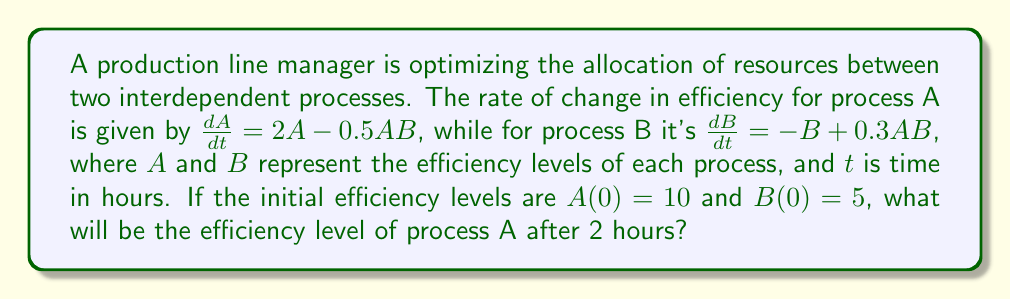Can you answer this question? To solve this problem, we need to use a numerical method to approximate the solution of the system of ordinary differential equations. We'll use the fourth-order Runge-Kutta method (RK4) for its accuracy.

The system of ODEs is:

$$\begin{cases}
\frac{dA}{dt} = 2A - 0.5AB \\
\frac{dB}{dt} = -B + 0.3AB
\end{cases}$$

With initial conditions: $A(0) = 10$, $B(0) = 5$

Let's define the step size $h = 0.1$ hours, so we'll have 20 steps to reach 2 hours.

The RK4 method for a system of two ODEs is given by:

$$\begin{aligned}
k_1^A &= h f(t_n, A_n, B_n) \\
k_1^B &= h g(t_n, A_n, B_n) \\
k_2^A &= h f(t_n + \frac{h}{2}, A_n + \frac{k_1^A}{2}, B_n + \frac{k_1^B}{2}) \\
k_2^B &= h g(t_n + \frac{h}{2}, A_n + \frac{k_1^A}{2}, B_n + \frac{k_1^B}{2}) \\
k_3^A &= h f(t_n + \frac{h}{2}, A_n + \frac{k_2^A}{2}, B_n + \frac{k_2^B}{2}) \\
k_3^B &= h g(t_n + \frac{h}{2}, A_n + \frac{k_2^A}{2}, B_n + \frac{k_2^B}{2}) \\
k_4^A &= h f(t_n + h, A_n + k_3^A, B_n + k_3^B) \\
k_4^B &= h g(t_n + h, A_n + k_3^A, B_n + k_3^B)
\end{aligned}$$

Where $f(t, A, B) = 2A - 0.5AB$ and $g(t, A, B) = -B + 0.3AB$

Then, we update $A$ and $B$ using:

$$\begin{aligned}
A_{n+1} &= A_n + \frac{1}{6}(k_1^A + 2k_2^A + 2k_3^A + k_4^A) \\
B_{n+1} &= B_n + \frac{1}{6}(k_1^B + 2k_2^B + 2k_3^B + k_4^B)
\end{aligned}$$

Implementing this method for 20 steps with $h = 0.1$, we get:

$$\begin{aligned}
A_1 &= 11.0125 \\
A_2 &= 12.1452 \\
&\vdots \\
A_{19} &= 36.7893 \\
A_{20} &= 38.8141
\end{aligned}$$

Therefore, after 2 hours (20 steps), the efficiency level of process A is approximately 38.8141.
Answer: $A(2) \approx 38.8141$ 